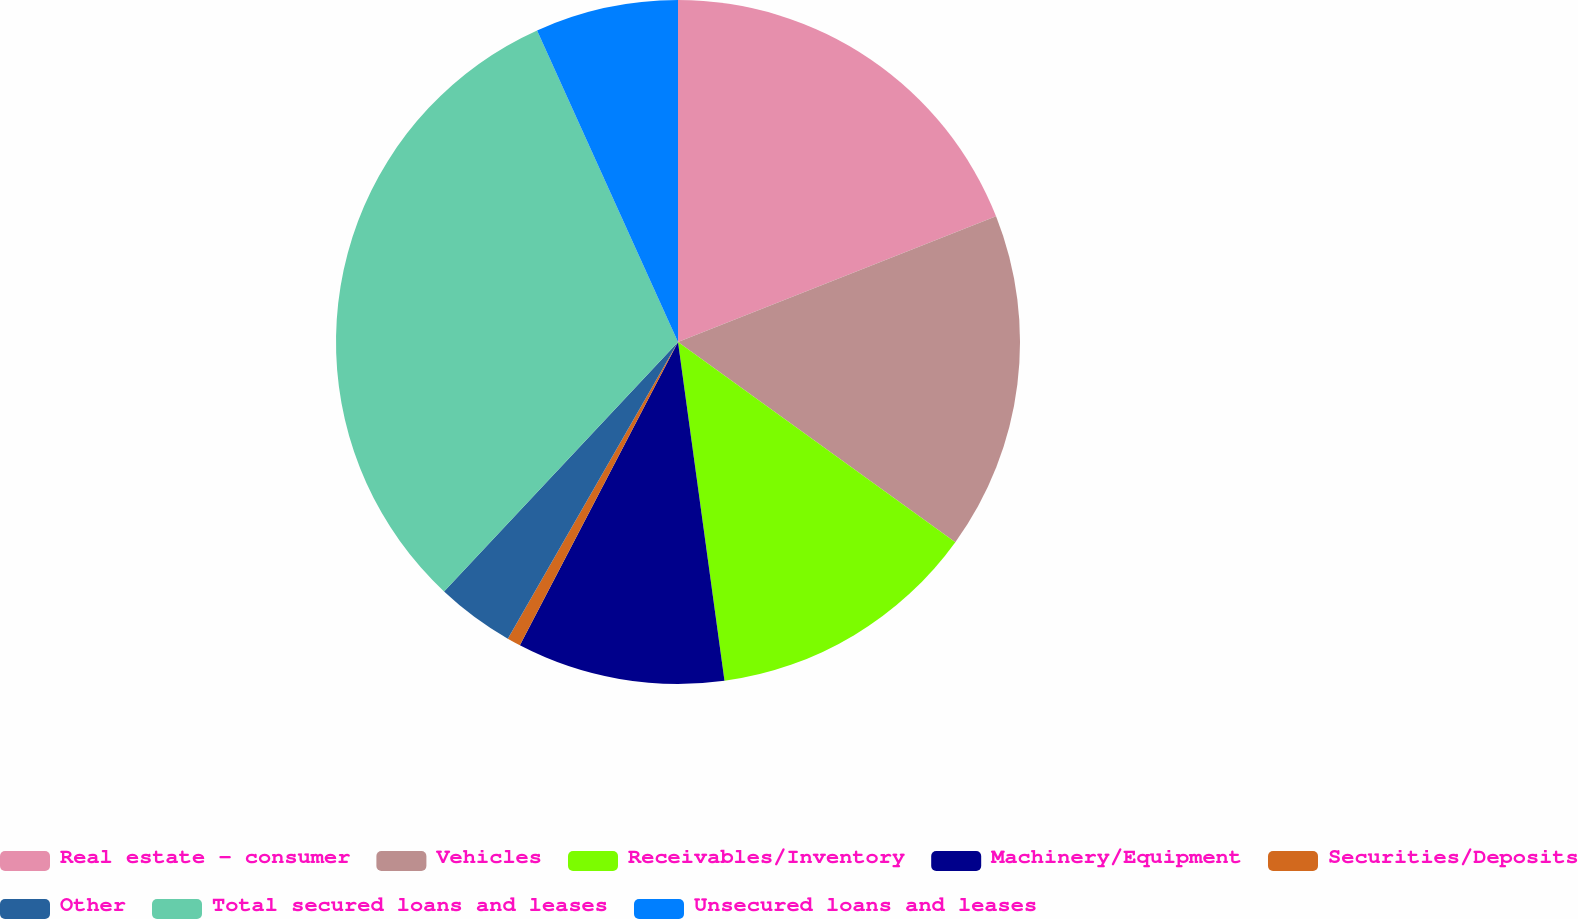Convert chart. <chart><loc_0><loc_0><loc_500><loc_500><pie_chart><fcel>Real estate - consumer<fcel>Vehicles<fcel>Receivables/Inventory<fcel>Machinery/Equipment<fcel>Securities/Deposits<fcel>Other<fcel>Total secured loans and leases<fcel>Unsecured loans and leases<nl><fcel>19.01%<fcel>15.94%<fcel>12.88%<fcel>9.82%<fcel>0.64%<fcel>3.7%<fcel>31.25%<fcel>6.76%<nl></chart> 